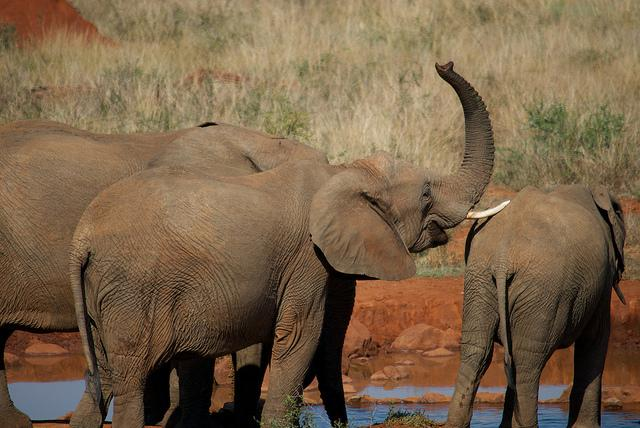What is not unique about this animals?

Choices:
A) have husks
B) large ears
C) have trunks
D) four legs four legs 